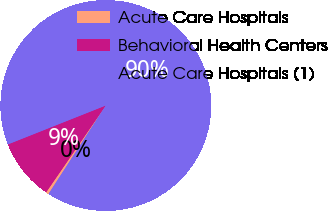<chart> <loc_0><loc_0><loc_500><loc_500><pie_chart><fcel>Acute Care Hospitals<fcel>Behavioral Health Centers<fcel>Acute Care Hospitals (1)<nl><fcel>0.43%<fcel>9.4%<fcel>90.17%<nl></chart> 